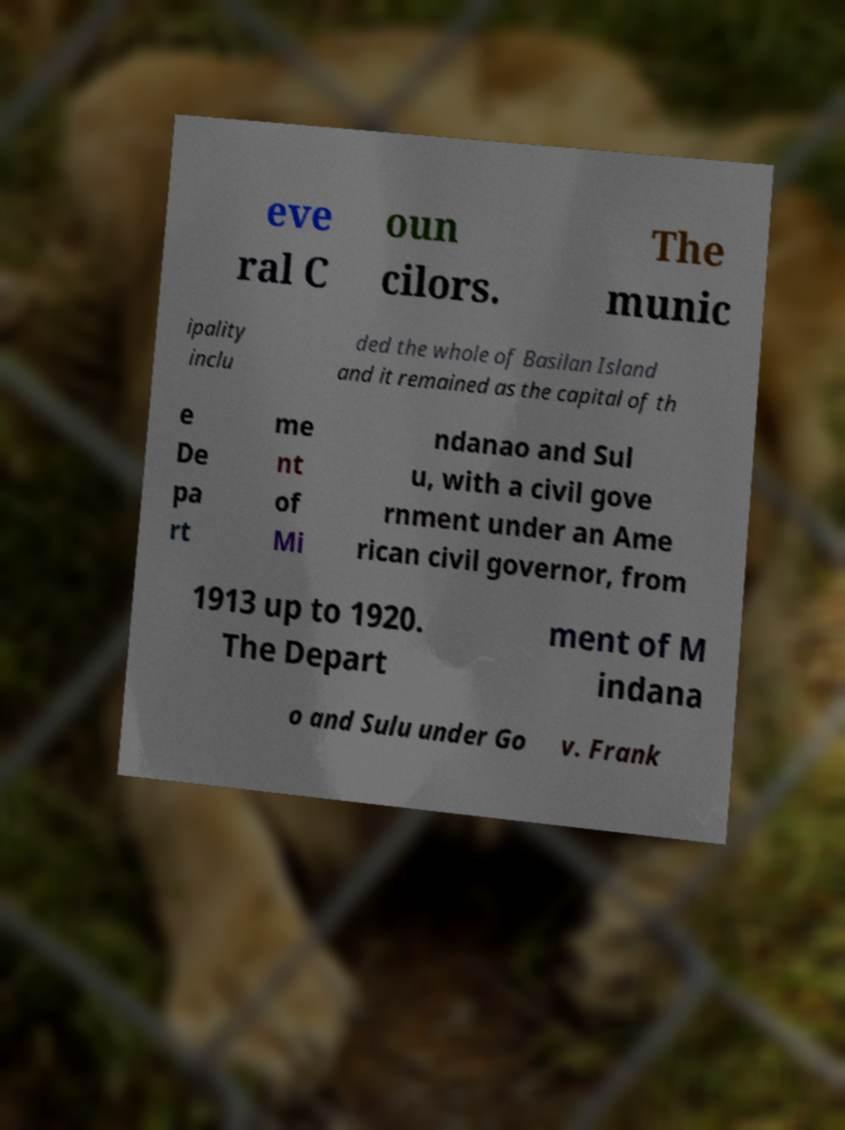What messages or text are displayed in this image? I need them in a readable, typed format. eve ral C oun cilors. The munic ipality inclu ded the whole of Basilan Island and it remained as the capital of th e De pa rt me nt of Mi ndanao and Sul u, with a civil gove rnment under an Ame rican civil governor, from 1913 up to 1920. The Depart ment of M indana o and Sulu under Go v. Frank 